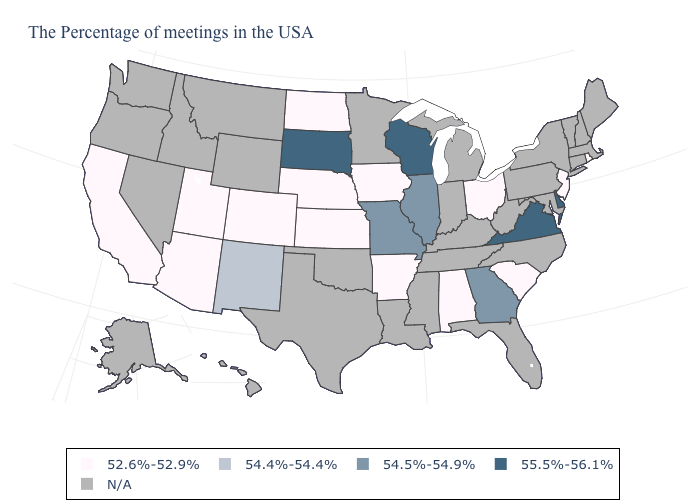What is the lowest value in the South?
Answer briefly. 52.6%-52.9%. What is the value of Virginia?
Be succinct. 55.5%-56.1%. Does Arkansas have the lowest value in the USA?
Concise answer only. Yes. Does South Dakota have the highest value in the USA?
Give a very brief answer. Yes. Which states have the lowest value in the Northeast?
Write a very short answer. Rhode Island, New Jersey. Name the states that have a value in the range 55.5%-56.1%?
Write a very short answer. Delaware, Virginia, Wisconsin, South Dakota. What is the lowest value in the USA?
Keep it brief. 52.6%-52.9%. Which states have the lowest value in the USA?
Concise answer only. Rhode Island, New Jersey, South Carolina, Ohio, Alabama, Arkansas, Iowa, Kansas, Nebraska, North Dakota, Colorado, Utah, Arizona, California. What is the highest value in the USA?
Concise answer only. 55.5%-56.1%. Which states hav the highest value in the MidWest?
Write a very short answer. Wisconsin, South Dakota. Does Georgia have the highest value in the USA?
Give a very brief answer. No. What is the value of Alabama?
Short answer required. 52.6%-52.9%. 